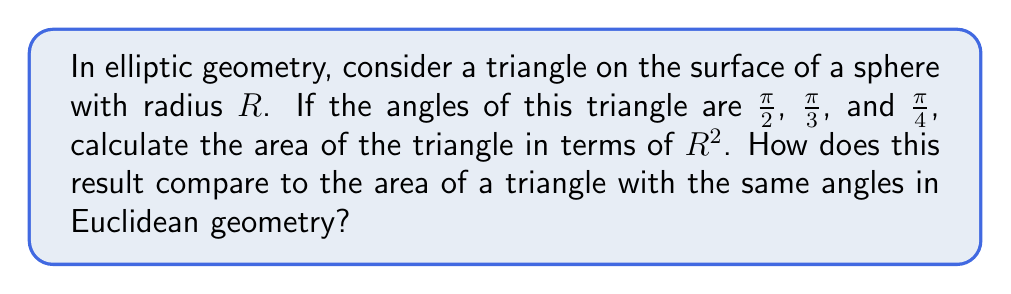Give your solution to this math problem. Let's approach this step-by-step:

1) In elliptic geometry, the sum of the angles in a triangle is greater than $\pi$ radians (180°). The excess is directly related to the area of the triangle.

2) The sum of the angles in this triangle is:
   $$\frac{\pi}{2} + \frac{\pi}{3} + \frac{\pi}{4} = \frac{6\pi + 4\pi + 3\pi}{12} = \frac{13\pi}{12}$$

3) The excess angle $E$ is the difference between this sum and $\pi$:
   $$E = \frac{13\pi}{12} - \pi = \frac{\pi}{12}$$

4) In elliptic geometry on a sphere of radius $R$, the area $A$ of a triangle is given by:
   $$A = R^2E$$

5) Substituting our excess angle:
   $$A = R^2 \cdot \frac{\pi}{12} = \frac{\pi R^2}{12}$$

6) In Euclidean geometry, the area of a triangle is zero when the sum of its angles is exactly $\pi$. Any triangle with the given angles would be impossible in Euclidean geometry, as the angle sum exceeds $\pi$.

7) To visualize this, we can use Asymptote to draw the spherical triangle:

[asy]
import geometry;

size(200);
currentprojection=orthographic(4,4,2);

real R = 2;
triple A = (R,0,0);
triple B = (0,R,0);
triple C = (0,0,R);

draw(surface(sphere(O,R)), paleblue+opacity(0.2));
draw(arc(O,A,B), blue);
draw(arc(O,B,C), blue);
draw(arc(O,C,A), blue);

dot("A", A, N);
dot("B", B, N);
dot("C", C, N);
[/asy]

This diagram shows a spherical triangle ABC on the surface of a sphere, where the angles at A, B, and C are $\frac{\pi}{2}$, $\frac{\pi}{3}$, and $\frac{\pi}{4}$ respectively.
Answer: $\frac{\pi R^2}{12}$; impossible in Euclidean geometry 